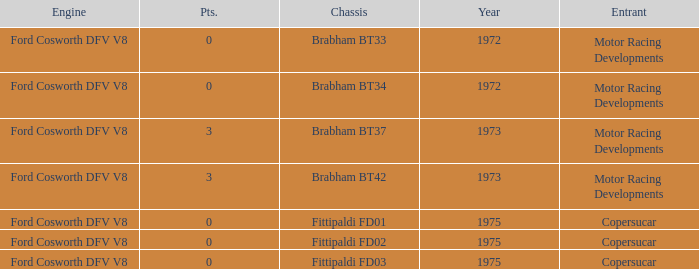Which engine from 1973 has a Brabham bt37 chassis? Ford Cosworth DFV V8. 